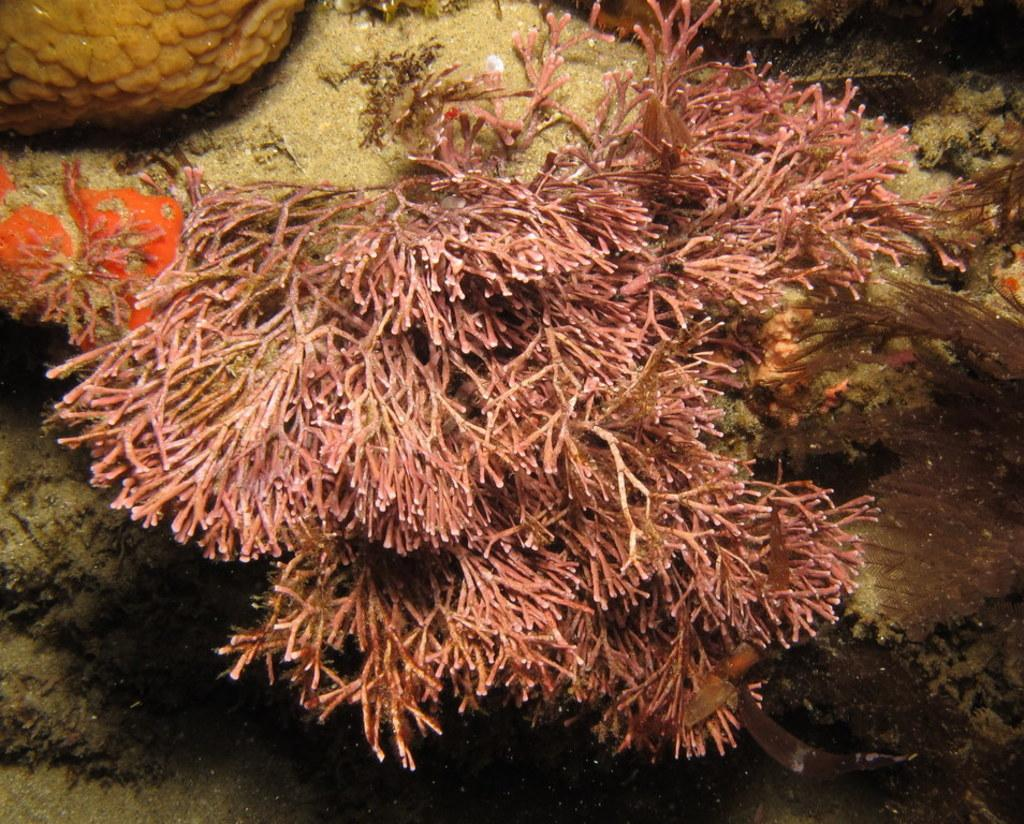What type of vegetation can be seen in the image? There is sea grass visible in the image. Where is the sea grass located? The sea grass is underwater. What else can be found in the underwater environment depicted in the image? There are objects present in the sea. What type of leather can be seen on the turkey in the image? There is no turkey or leather present in the image; it features underwater sea grass and objects. 